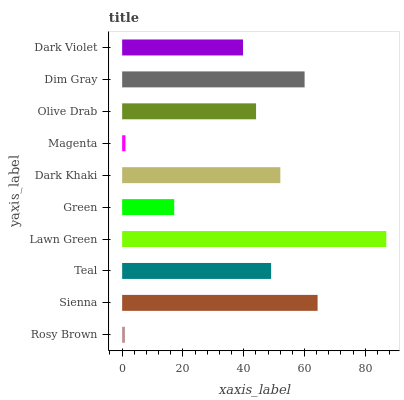Is Rosy Brown the minimum?
Answer yes or no. Yes. Is Lawn Green the maximum?
Answer yes or no. Yes. Is Sienna the minimum?
Answer yes or no. No. Is Sienna the maximum?
Answer yes or no. No. Is Sienna greater than Rosy Brown?
Answer yes or no. Yes. Is Rosy Brown less than Sienna?
Answer yes or no. Yes. Is Rosy Brown greater than Sienna?
Answer yes or no. No. Is Sienna less than Rosy Brown?
Answer yes or no. No. Is Teal the high median?
Answer yes or no. Yes. Is Olive Drab the low median?
Answer yes or no. Yes. Is Magenta the high median?
Answer yes or no. No. Is Sienna the low median?
Answer yes or no. No. 